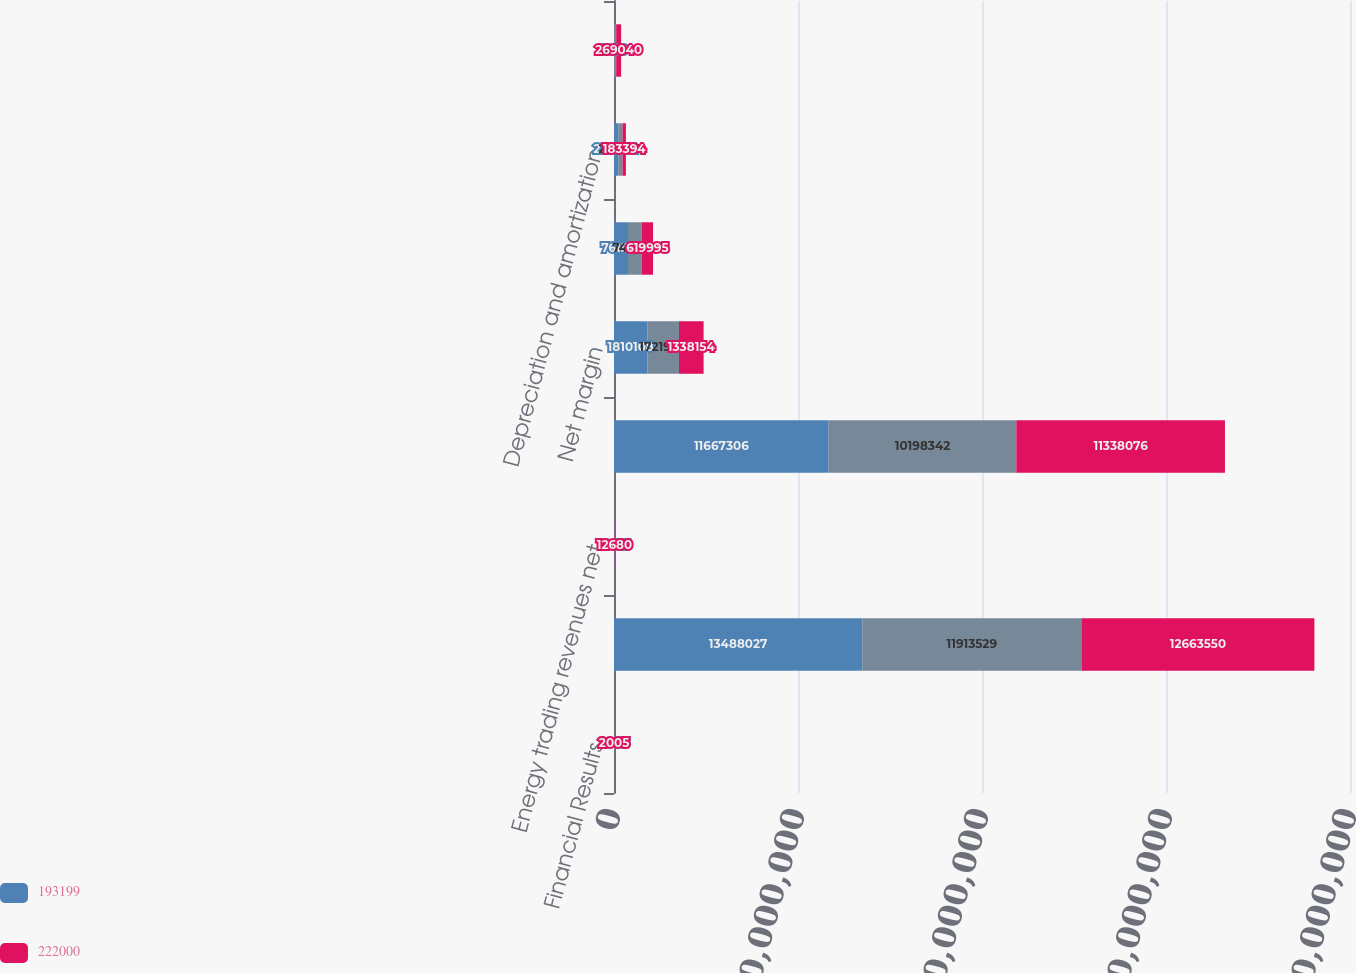Convert chart to OTSL. <chart><loc_0><loc_0><loc_500><loc_500><stacked_bar_chart><ecel><fcel>Financial Results<fcel>Operating revenues excluding<fcel>Energy trading revenues net<fcel>Cost of sales and fuel<fcel>Net margin<fcel>Operating costs<fcel>Depreciation and amortization<fcel>Gain (loss) on sale of assets<nl><fcel>193199<fcel>2007<fcel>1.3488e+07<fcel>10613<fcel>1.16673e+07<fcel>1.81011e+06<fcel>761510<fcel>227964<fcel>1909<nl><fcel>nan<fcel>2006<fcel>1.19135e+07<fcel>6797<fcel>1.01983e+07<fcel>1.72198e+06<fcel>740767<fcel>235543<fcel>116528<nl><fcel>222000<fcel>2005<fcel>1.26636e+07<fcel>12680<fcel>1.13381e+07<fcel>1.33815e+06<fcel>619995<fcel>183394<fcel>269040<nl></chart> 